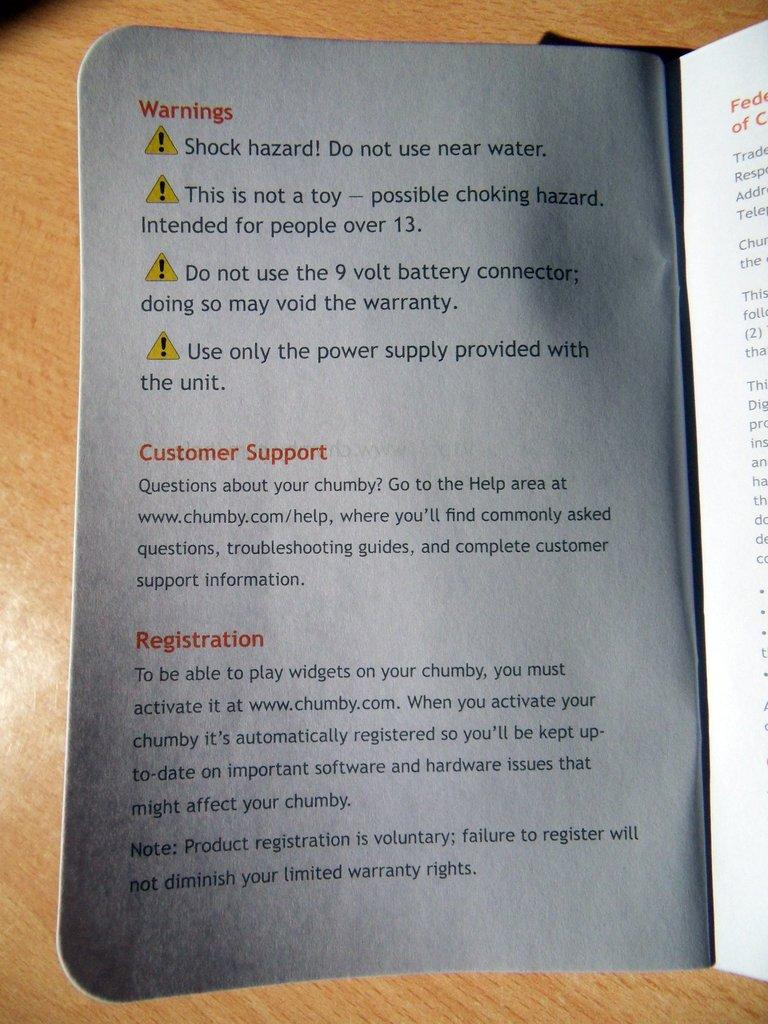What does the red text say at the very top?
Keep it short and to the point. Warnings. 